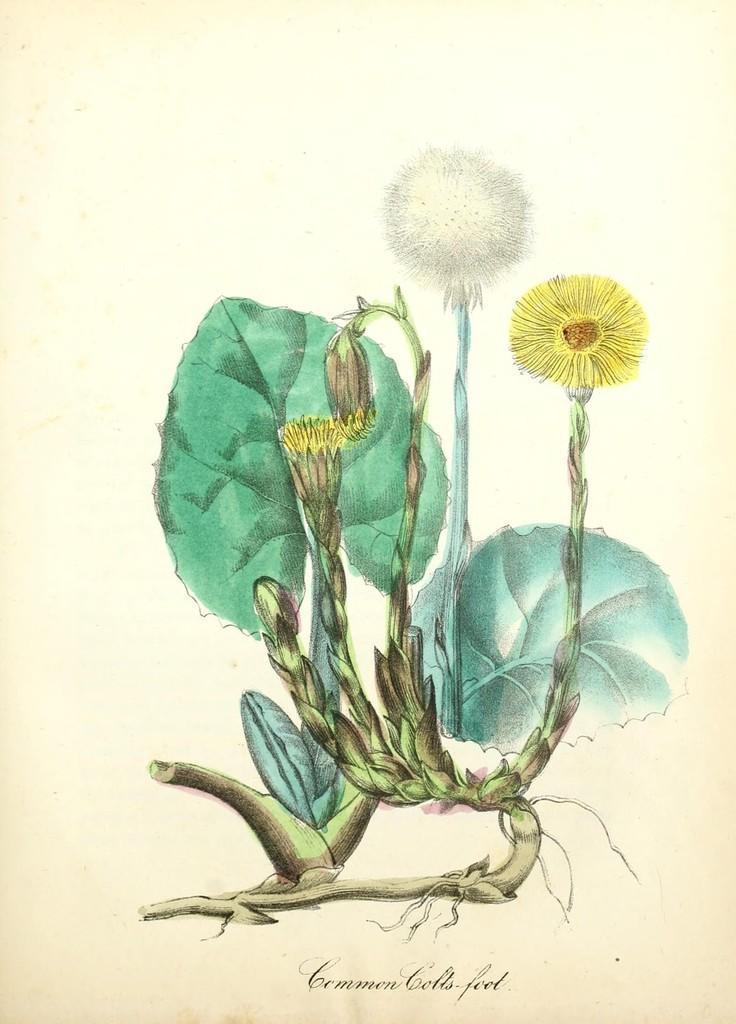What is depicted in the painting in the image? There is a painting of a plant in the image. What specific elements are included in the painting? The painting includes flowers and leaves. Is there any text present in the painting? Yes, there is text at the bottom of the painting. What is the color of the background in the painting? The background of the painting is white. Can you see a snake slithering through the flowers in the painting? No, there is no snake present in the painting; it only features a plant with flowers and leaves. How many toes are visible on the painting? There are no toes depicted in the painting, as it is a painting of a plant with flowers and leaves. 